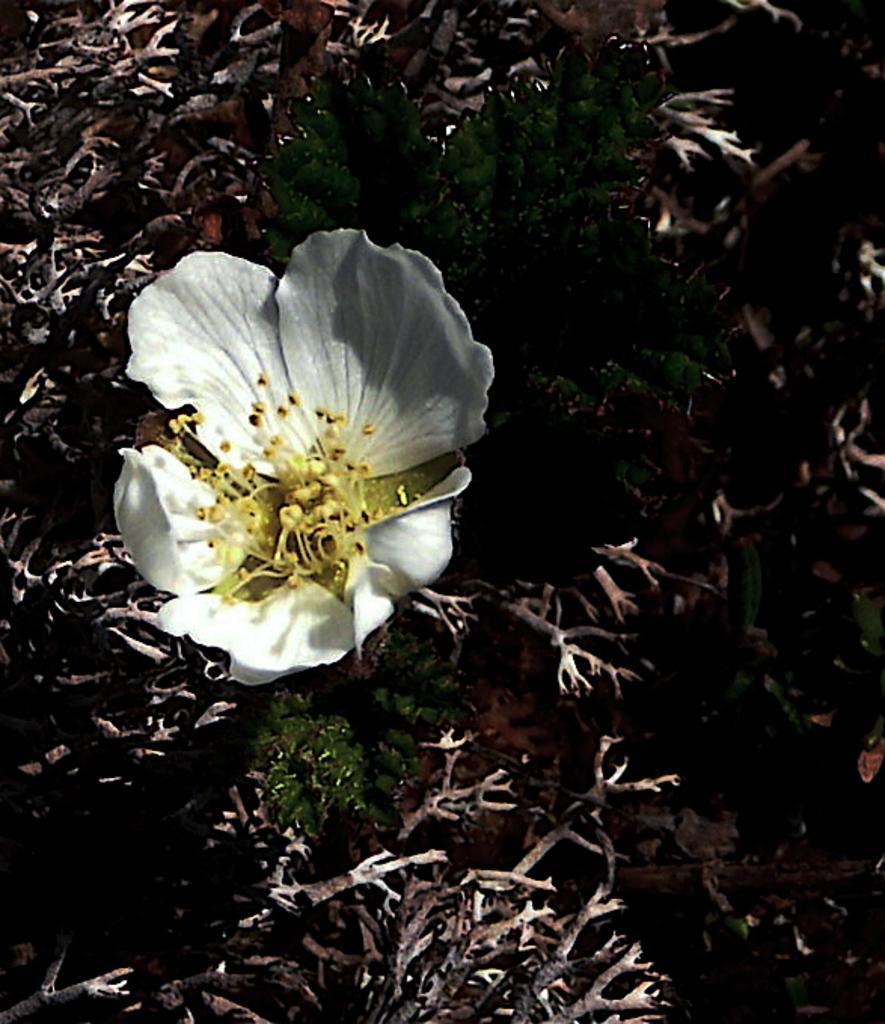Describe this image in one or two sentences. In this image I can see a white color flower, its plant and other dried stems and leaves. 